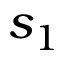<formula> <loc_0><loc_0><loc_500><loc_500>s _ { 1 }</formula> 